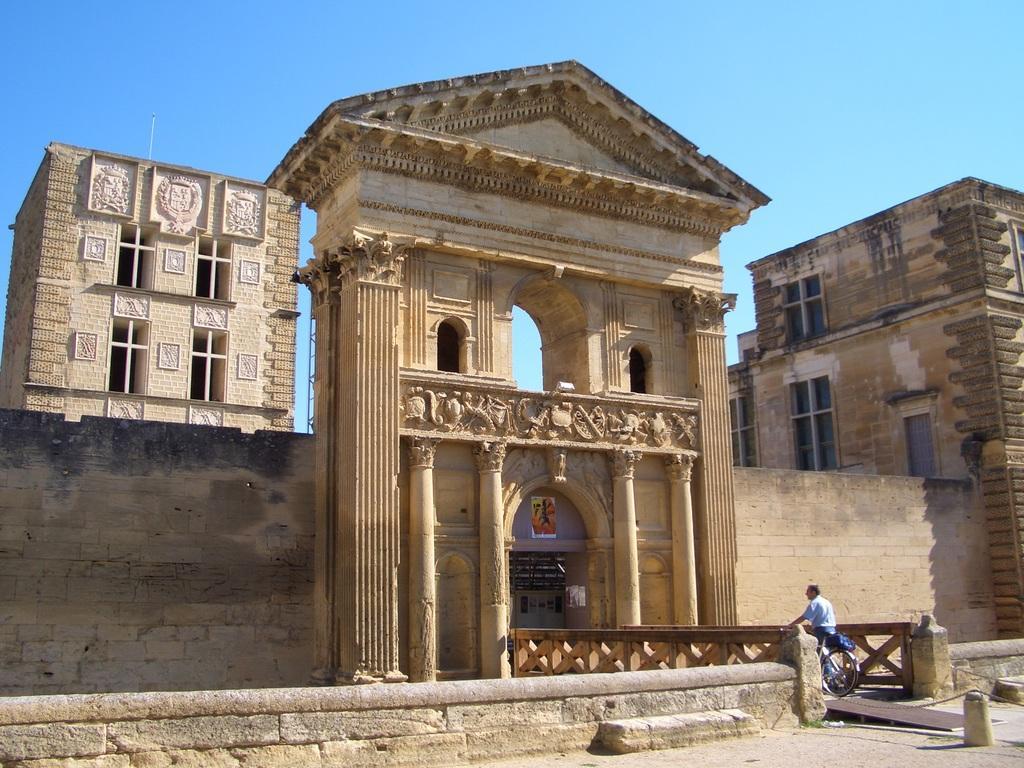Can you describe this image briefly? In this picture we can see buildings. Here we can see a poster. There is a wall. Here we can see a person on the bicycle. In the background there is sky. 